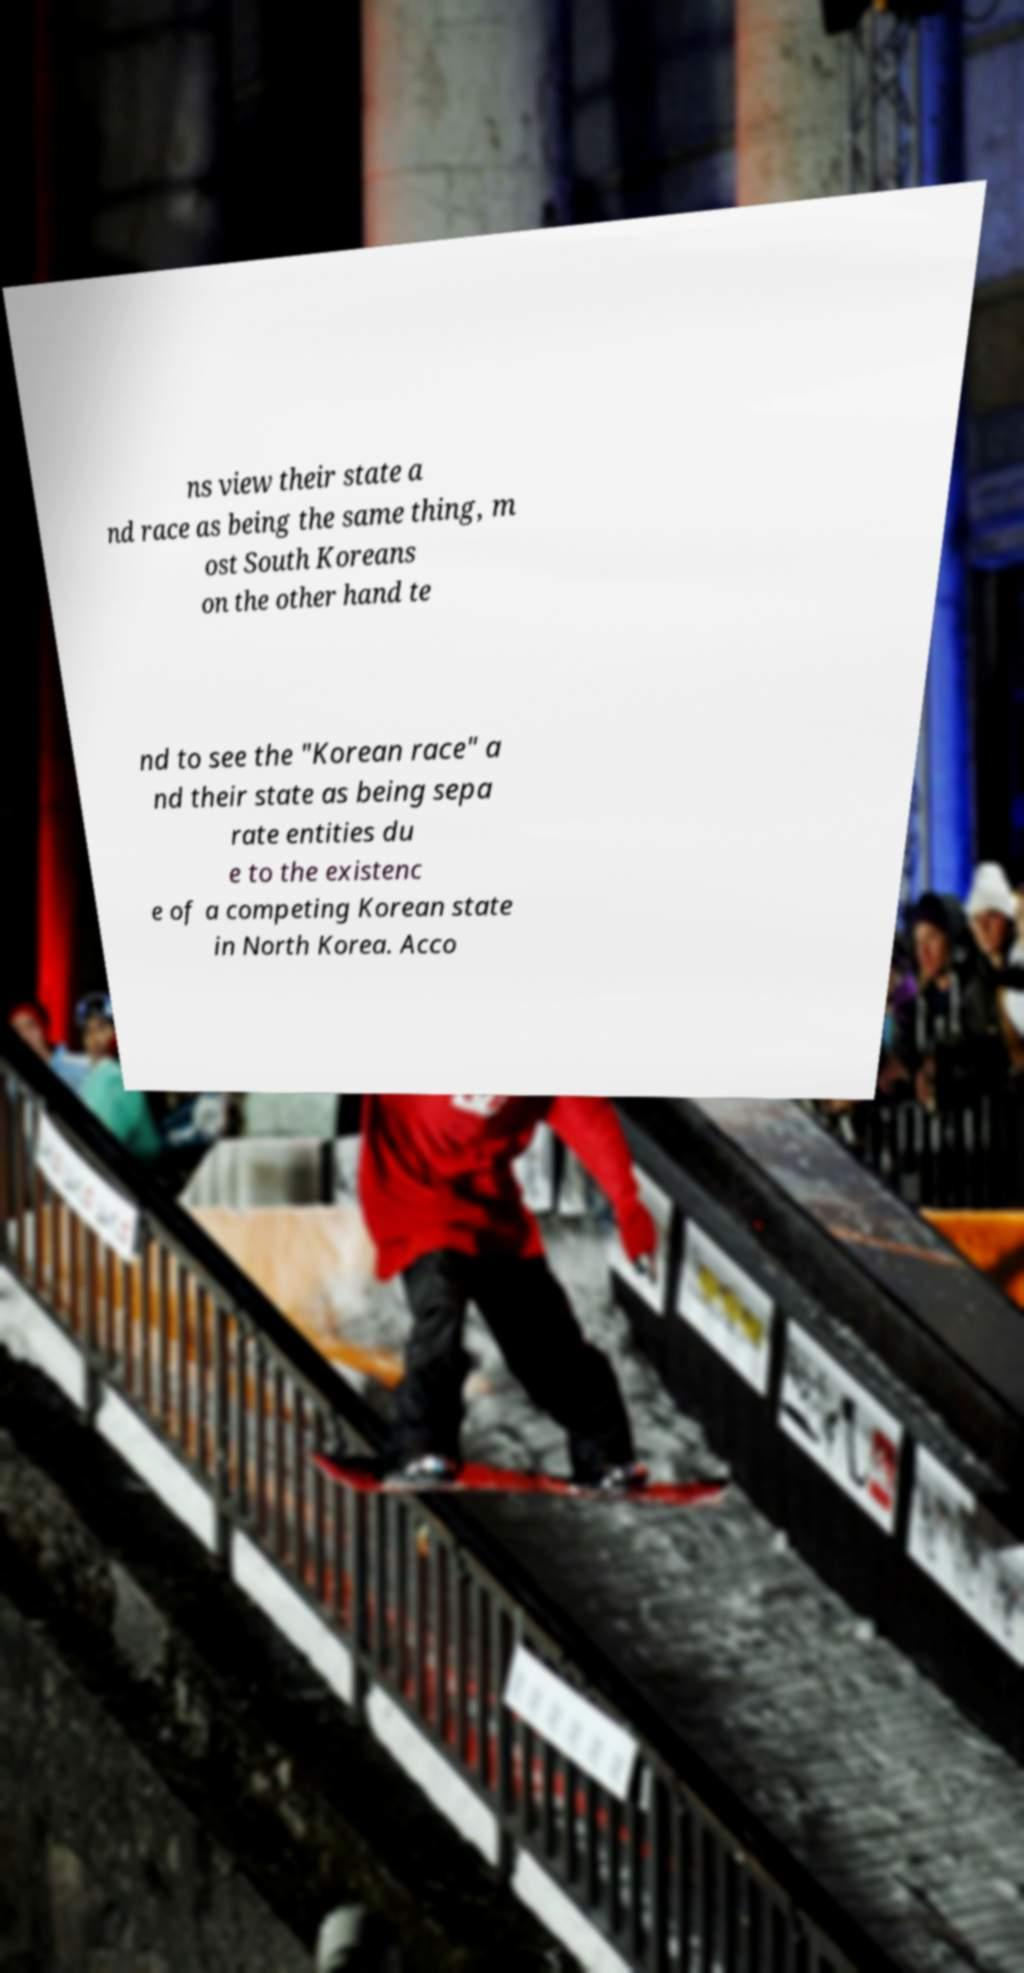Can you read and provide the text displayed in the image?This photo seems to have some interesting text. Can you extract and type it out for me? ns view their state a nd race as being the same thing, m ost South Koreans on the other hand te nd to see the "Korean race" a nd their state as being sepa rate entities du e to the existenc e of a competing Korean state in North Korea. Acco 